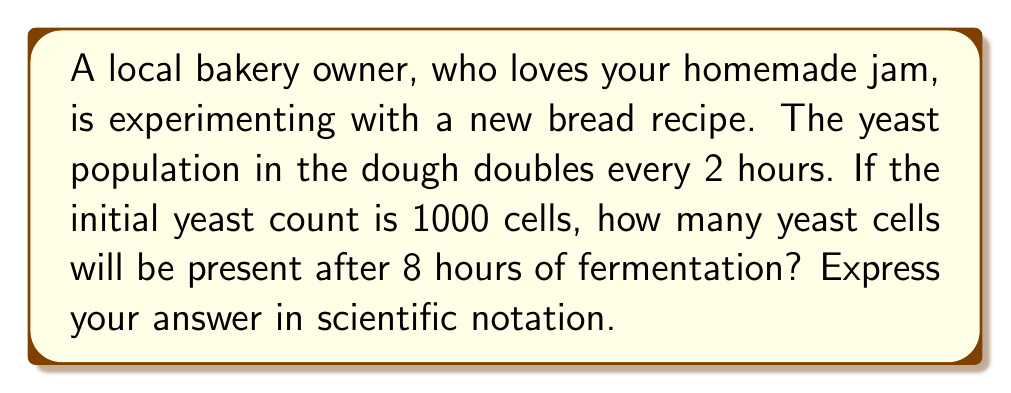What is the answer to this math problem? Let's approach this step-by-step using the exponential growth formula:

1) The exponential growth formula is:
   $$A = P(1 + r)^t$$
   Where:
   $A$ = Final amount
   $P$ = Initial amount
   $r$ = Growth rate
   $t$ = Time periods

2) In this case:
   $P = 1000$ (initial yeast count)
   $t = 4$ (8 hours ÷ 2 hours per doubling)
   $r = 1$ (100% growth rate, as the population doubles)

3) Substituting these values:
   $$A = 1000(1 + 1)^4$$

4) Simplify:
   $$A = 1000(2)^4$$

5) Calculate:
   $$A = 1000 \times 16 = 16000$$

6) Convert to scientific notation:
   $$A = 1.6 \times 10^4$$

Thus, after 8 hours, there will be $1.6 \times 10^4$ yeast cells in the dough.
Answer: $1.6 \times 10^4$ 